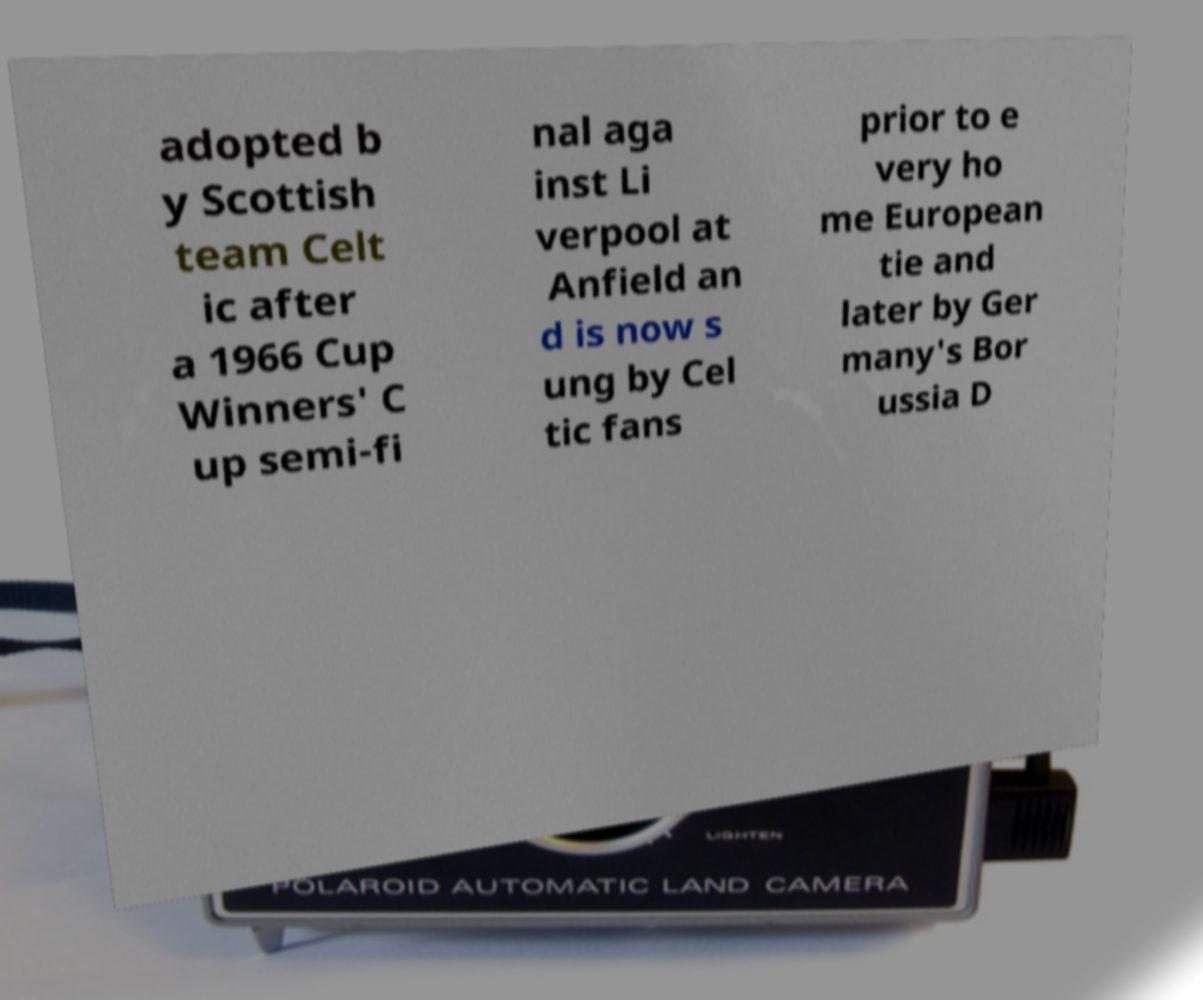There's text embedded in this image that I need extracted. Can you transcribe it verbatim? adopted b y Scottish team Celt ic after a 1966 Cup Winners' C up semi-fi nal aga inst Li verpool at Anfield an d is now s ung by Cel tic fans prior to e very ho me European tie and later by Ger many's Bor ussia D 